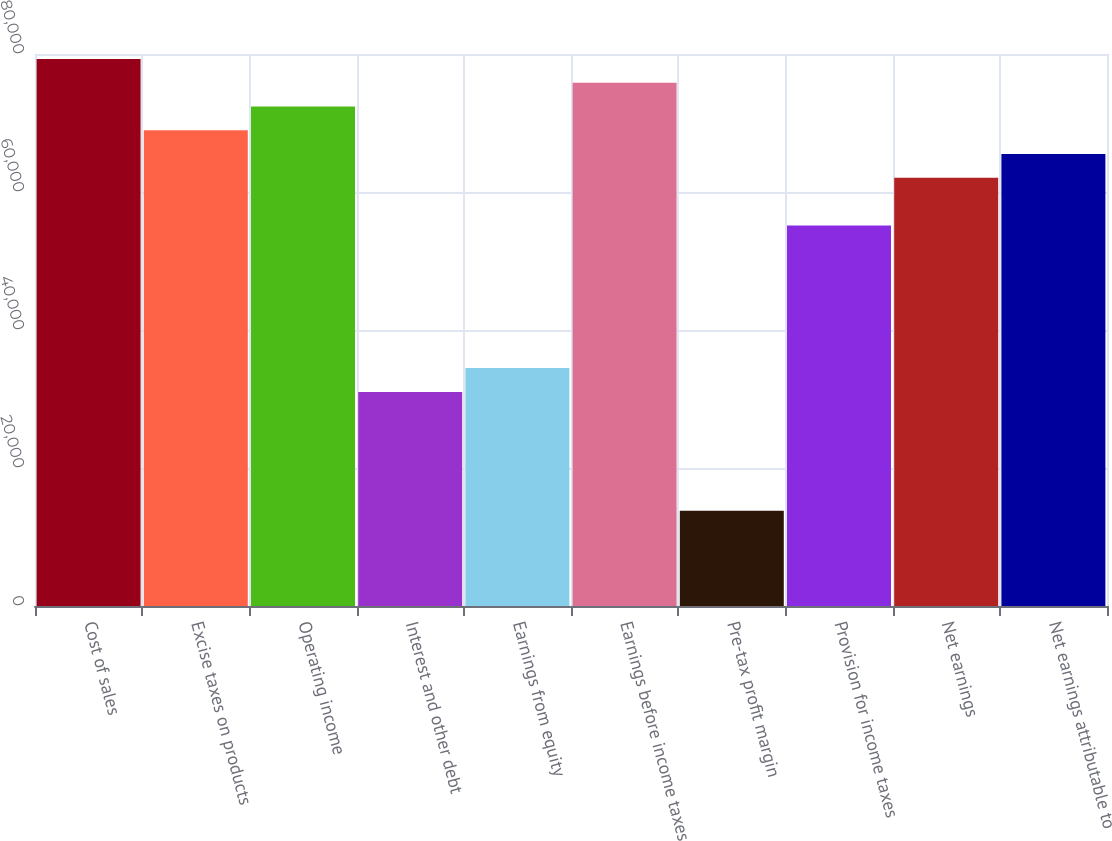Convert chart. <chart><loc_0><loc_0><loc_500><loc_500><bar_chart><fcel>Cost of sales<fcel>Excise taxes on products<fcel>Operating income<fcel>Interest and other debt<fcel>Earnings from equity<fcel>Earnings before income taxes<fcel>Pre-tax profit margin<fcel>Provision for income taxes<fcel>Net earnings<fcel>Net earnings attributable to<nl><fcel>79290.6<fcel>68948.5<fcel>72395.9<fcel>31027.7<fcel>34475<fcel>75843.2<fcel>13790.9<fcel>55159.1<fcel>62053.8<fcel>65501.2<nl></chart> 